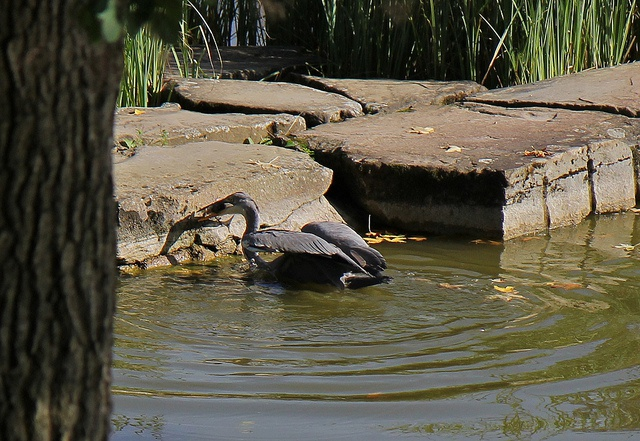Describe the objects in this image and their specific colors. I can see a bird in black, gray, and darkgray tones in this image. 